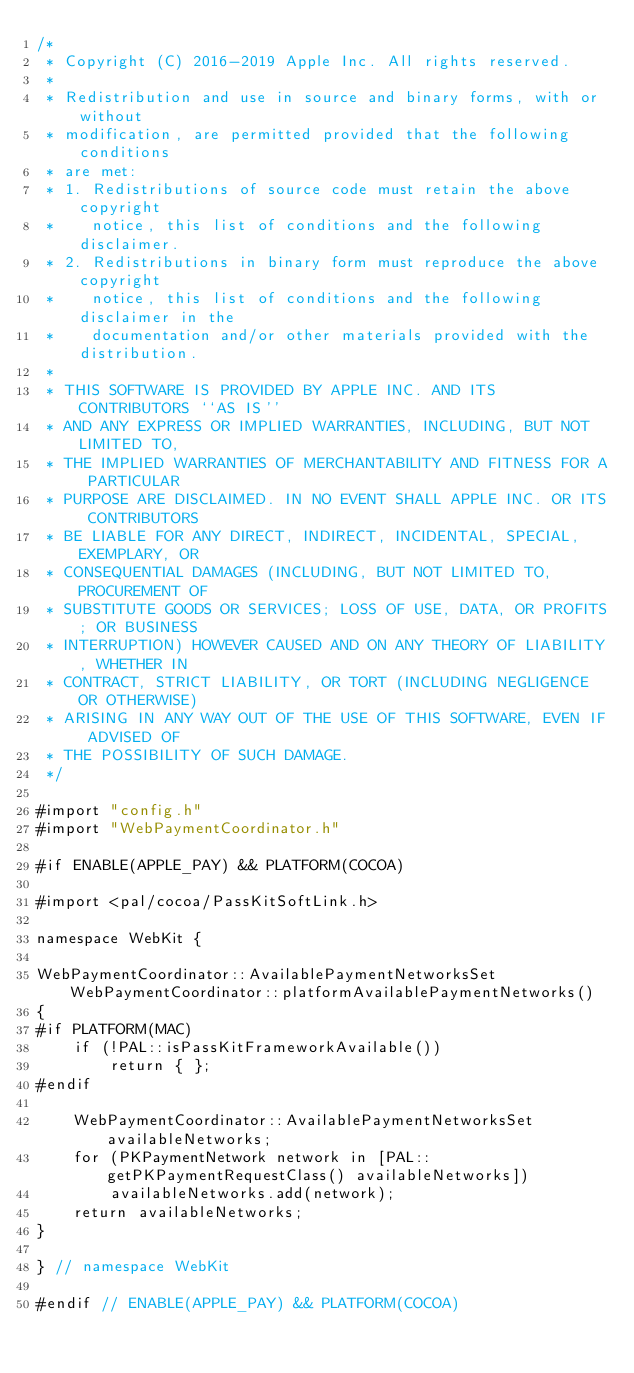<code> <loc_0><loc_0><loc_500><loc_500><_ObjectiveC_>/*
 * Copyright (C) 2016-2019 Apple Inc. All rights reserved.
 *
 * Redistribution and use in source and binary forms, with or without
 * modification, are permitted provided that the following conditions
 * are met:
 * 1. Redistributions of source code must retain the above copyright
 *    notice, this list of conditions and the following disclaimer.
 * 2. Redistributions in binary form must reproduce the above copyright
 *    notice, this list of conditions and the following disclaimer in the
 *    documentation and/or other materials provided with the distribution.
 *
 * THIS SOFTWARE IS PROVIDED BY APPLE INC. AND ITS CONTRIBUTORS ``AS IS''
 * AND ANY EXPRESS OR IMPLIED WARRANTIES, INCLUDING, BUT NOT LIMITED TO,
 * THE IMPLIED WARRANTIES OF MERCHANTABILITY AND FITNESS FOR A PARTICULAR
 * PURPOSE ARE DISCLAIMED. IN NO EVENT SHALL APPLE INC. OR ITS CONTRIBUTORS
 * BE LIABLE FOR ANY DIRECT, INDIRECT, INCIDENTAL, SPECIAL, EXEMPLARY, OR
 * CONSEQUENTIAL DAMAGES (INCLUDING, BUT NOT LIMITED TO, PROCUREMENT OF
 * SUBSTITUTE GOODS OR SERVICES; LOSS OF USE, DATA, OR PROFITS; OR BUSINESS
 * INTERRUPTION) HOWEVER CAUSED AND ON ANY THEORY OF LIABILITY, WHETHER IN
 * CONTRACT, STRICT LIABILITY, OR TORT (INCLUDING NEGLIGENCE OR OTHERWISE)
 * ARISING IN ANY WAY OUT OF THE USE OF THIS SOFTWARE, EVEN IF ADVISED OF
 * THE POSSIBILITY OF SUCH DAMAGE.
 */

#import "config.h"
#import "WebPaymentCoordinator.h"

#if ENABLE(APPLE_PAY) && PLATFORM(COCOA)

#import <pal/cocoa/PassKitSoftLink.h>

namespace WebKit {

WebPaymentCoordinator::AvailablePaymentNetworksSet WebPaymentCoordinator::platformAvailablePaymentNetworks()
{
#if PLATFORM(MAC)
    if (!PAL::isPassKitFrameworkAvailable())
        return { };
#endif

    WebPaymentCoordinator::AvailablePaymentNetworksSet availableNetworks;
    for (PKPaymentNetwork network in [PAL::getPKPaymentRequestClass() availableNetworks])
        availableNetworks.add(network);
    return availableNetworks;
}

} // namespace WebKit

#endif // ENABLE(APPLE_PAY) && PLATFORM(COCOA)
</code> 